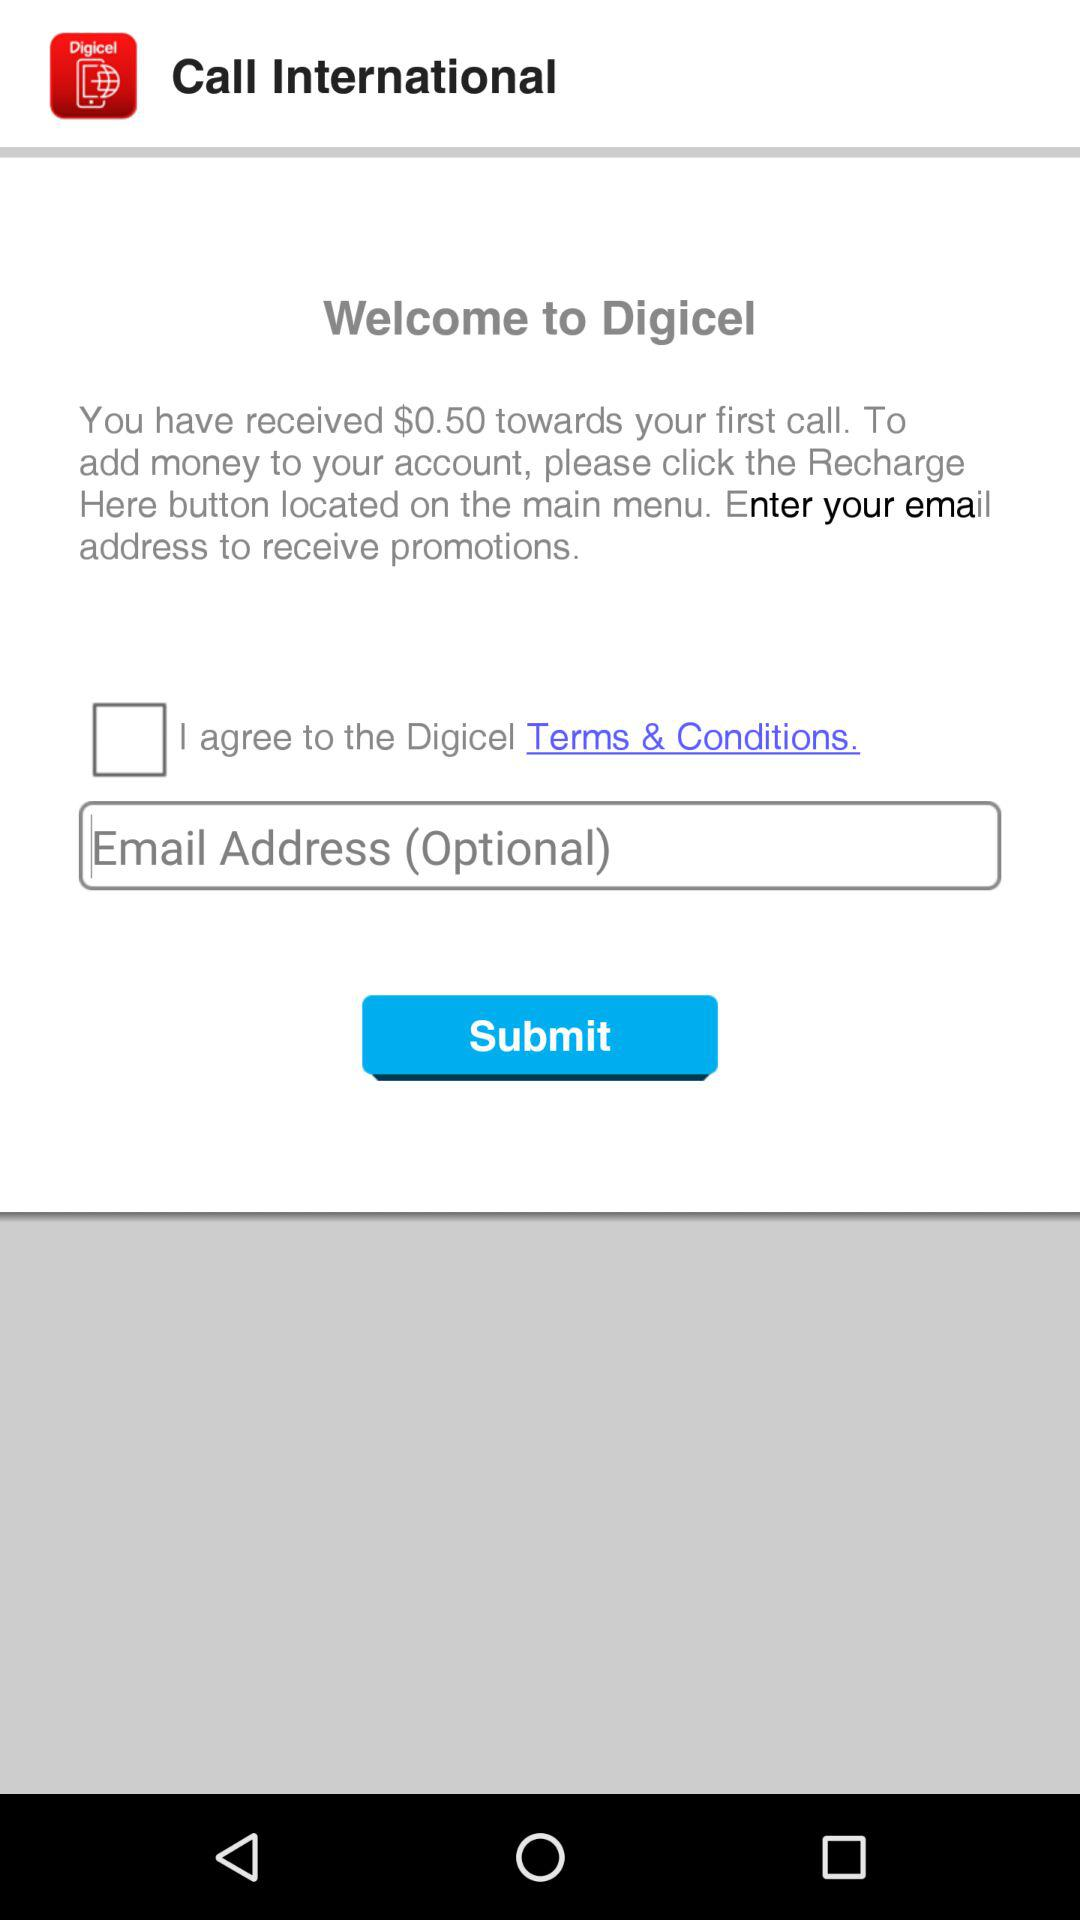How much money was received towards the first call? The money that was received towards the first call is $0.50. 